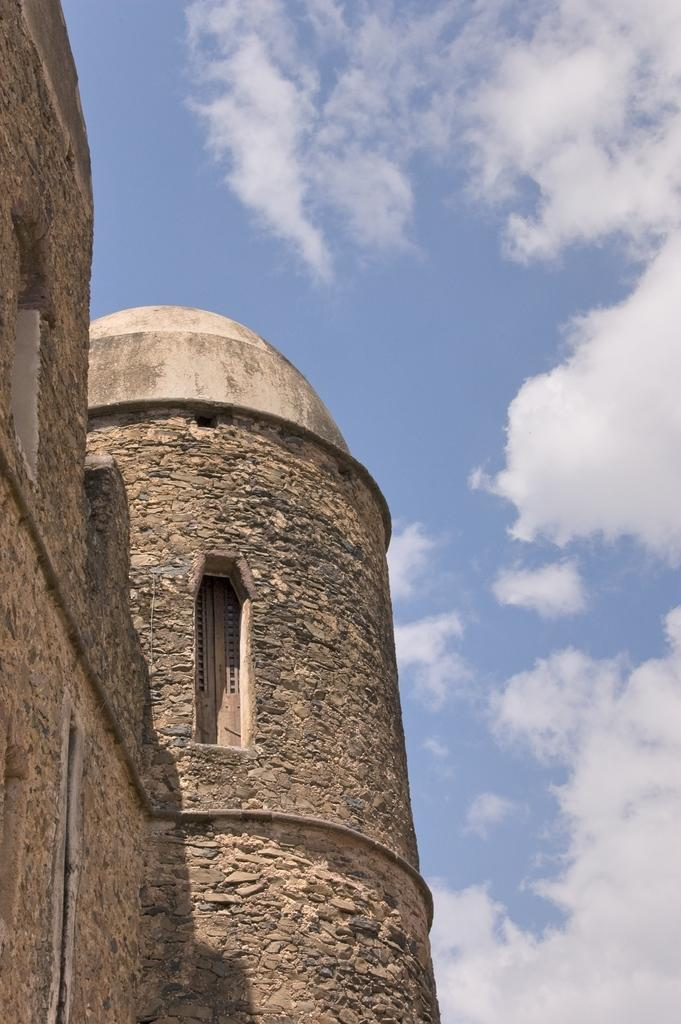What type of structure is present in the image? There is a building in the image. What feature can be seen on the building? The building has windows. What can be seen in the background of the image? There is sky visible in the background of the image. What is the condition of the sky in the image? There are clouds in the sky. Can you tell me how many worms are crawling on the building in the image? There are no worms present in the image; it features a building with windows and a cloudy sky. What type of lumber is used to construct the building in the image? The image does not provide information about the type of lumber used to construct the building. 